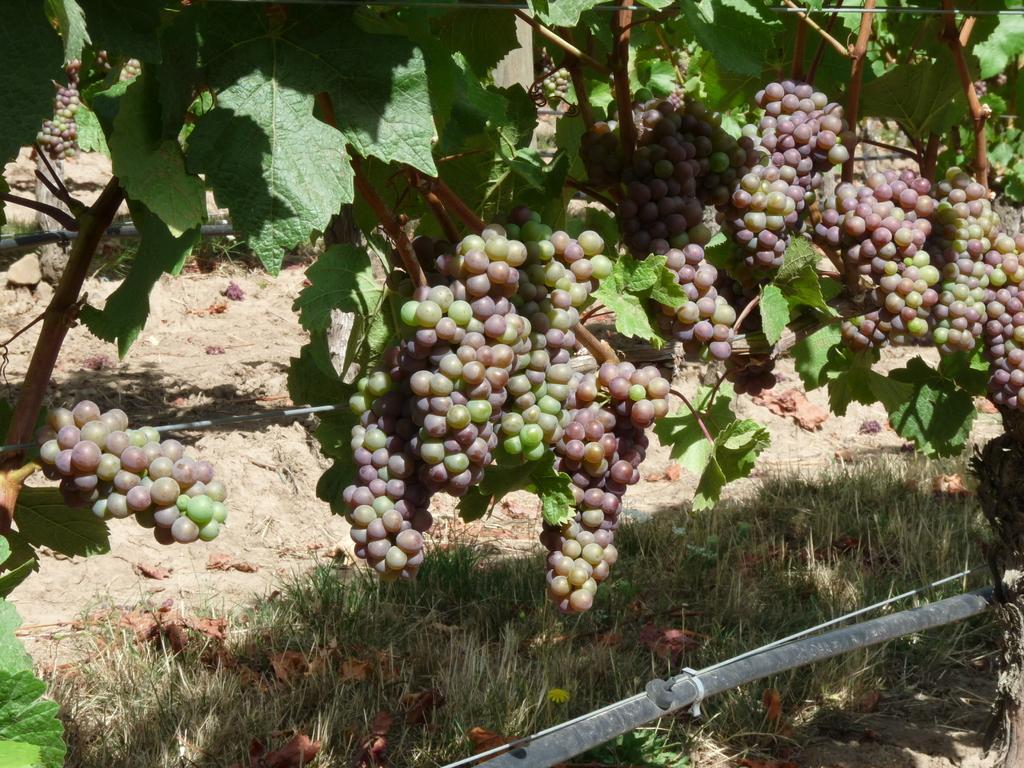In one or two sentences, can you explain what this image depicts? In the image there is a grape tree, there are a lot of grape fruits to the tree, below the tree there is a grass. 